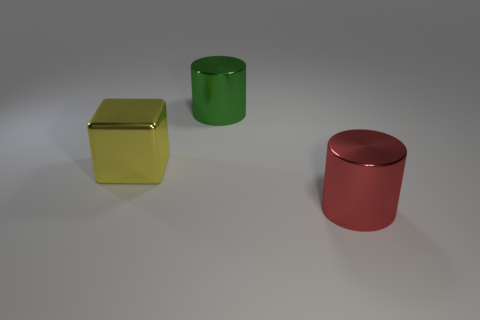Are there any other things of the same color as the large shiny cube?
Your answer should be compact. No. The metallic cylinder behind the red cylinder on the right side of the green object is what color?
Your response must be concise. Green. Is the number of things that are to the right of the large metallic block less than the number of big yellow shiny cubes in front of the big red metallic cylinder?
Keep it short and to the point. No. What number of things are metal objects in front of the big yellow cube or large cylinders?
Offer a very short reply. 2. Does the red cylinder that is right of the shiny block have the same size as the large green shiny cylinder?
Your response must be concise. Yes. Are there fewer metallic objects in front of the red metal object than tiny green metallic blocks?
Your response must be concise. No. What number of large objects are red metal cylinders or blocks?
Ensure brevity in your answer.  2. How many objects are either big shiny objects that are in front of the metallic block or things behind the red metallic thing?
Your answer should be compact. 3. Are there fewer purple balls than red objects?
Offer a very short reply. Yes. There is a yellow object that is the same size as the red object; what shape is it?
Make the answer very short. Cube. 